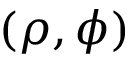Convert formula to latex. <formula><loc_0><loc_0><loc_500><loc_500>( \rho , \phi )</formula> 